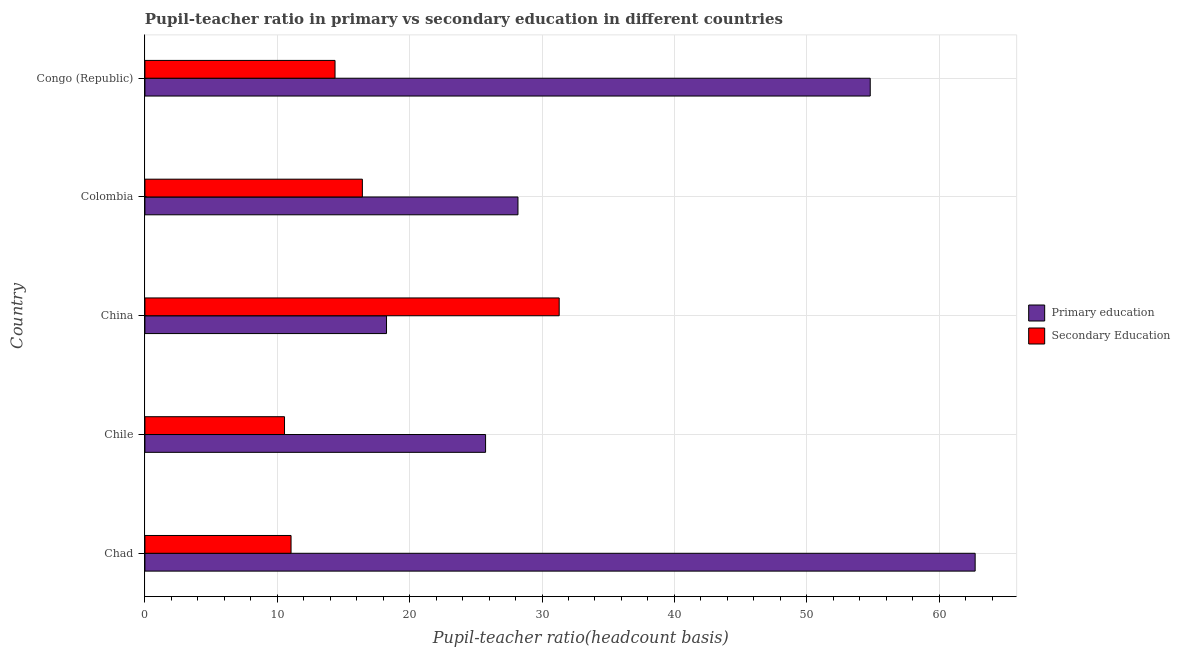How many different coloured bars are there?
Your response must be concise. 2. How many groups of bars are there?
Your answer should be compact. 5. Are the number of bars on each tick of the Y-axis equal?
Your response must be concise. Yes. How many bars are there on the 5th tick from the top?
Give a very brief answer. 2. What is the label of the 2nd group of bars from the top?
Your answer should be very brief. Colombia. What is the pupil-teacher ratio in primary education in Chad?
Provide a succinct answer. 62.72. Across all countries, what is the maximum pupil-teacher ratio in primary education?
Keep it short and to the point. 62.72. Across all countries, what is the minimum pupil-teacher ratio in primary education?
Give a very brief answer. 18.25. In which country was the pupil-teacher ratio in primary education maximum?
Your answer should be very brief. Chad. In which country was the pupil-teacher ratio in primary education minimum?
Provide a short and direct response. China. What is the total pupil teacher ratio on secondary education in the graph?
Your response must be concise. 83.67. What is the difference between the pupil teacher ratio on secondary education in Chad and that in Colombia?
Offer a terse response. -5.39. What is the difference between the pupil teacher ratio on secondary education in Colombia and the pupil-teacher ratio in primary education in Congo (Republic)?
Provide a succinct answer. -38.37. What is the average pupil teacher ratio on secondary education per country?
Offer a very short reply. 16.73. What is the difference between the pupil teacher ratio on secondary education and pupil-teacher ratio in primary education in China?
Your response must be concise. 13.05. In how many countries, is the pupil-teacher ratio in primary education greater than 58 ?
Offer a very short reply. 1. What is the ratio of the pupil teacher ratio on secondary education in Chad to that in China?
Offer a terse response. 0.35. Is the pupil-teacher ratio in primary education in Chile less than that in Colombia?
Make the answer very short. Yes. Is the difference between the pupil-teacher ratio in primary education in China and Congo (Republic) greater than the difference between the pupil teacher ratio on secondary education in China and Congo (Republic)?
Make the answer very short. No. What is the difference between the highest and the second highest pupil teacher ratio on secondary education?
Ensure brevity in your answer.  14.87. What is the difference between the highest and the lowest pupil-teacher ratio in primary education?
Offer a very short reply. 44.47. What does the 1st bar from the top in Chad represents?
Offer a very short reply. Secondary Education. How many bars are there?
Your response must be concise. 10. What is the difference between two consecutive major ticks on the X-axis?
Provide a short and direct response. 10. Are the values on the major ticks of X-axis written in scientific E-notation?
Provide a short and direct response. No. How are the legend labels stacked?
Ensure brevity in your answer.  Vertical. What is the title of the graph?
Provide a short and direct response. Pupil-teacher ratio in primary vs secondary education in different countries. Does "Forest land" appear as one of the legend labels in the graph?
Offer a very short reply. No. What is the label or title of the X-axis?
Your response must be concise. Pupil-teacher ratio(headcount basis). What is the Pupil-teacher ratio(headcount basis) in Primary education in Chad?
Ensure brevity in your answer.  62.72. What is the Pupil-teacher ratio(headcount basis) in Secondary Education in Chad?
Provide a short and direct response. 11.04. What is the Pupil-teacher ratio(headcount basis) in Primary education in Chile?
Ensure brevity in your answer.  25.74. What is the Pupil-teacher ratio(headcount basis) of Secondary Education in Chile?
Make the answer very short. 10.55. What is the Pupil-teacher ratio(headcount basis) in Primary education in China?
Offer a terse response. 18.25. What is the Pupil-teacher ratio(headcount basis) in Secondary Education in China?
Give a very brief answer. 31.3. What is the Pupil-teacher ratio(headcount basis) of Primary education in Colombia?
Provide a short and direct response. 28.18. What is the Pupil-teacher ratio(headcount basis) of Secondary Education in Colombia?
Your response must be concise. 16.43. What is the Pupil-teacher ratio(headcount basis) of Primary education in Congo (Republic)?
Make the answer very short. 54.8. What is the Pupil-teacher ratio(headcount basis) in Secondary Education in Congo (Republic)?
Give a very brief answer. 14.36. Across all countries, what is the maximum Pupil-teacher ratio(headcount basis) in Primary education?
Your answer should be compact. 62.72. Across all countries, what is the maximum Pupil-teacher ratio(headcount basis) in Secondary Education?
Make the answer very short. 31.3. Across all countries, what is the minimum Pupil-teacher ratio(headcount basis) in Primary education?
Ensure brevity in your answer.  18.25. Across all countries, what is the minimum Pupil-teacher ratio(headcount basis) in Secondary Education?
Your answer should be compact. 10.55. What is the total Pupil-teacher ratio(headcount basis) in Primary education in the graph?
Your answer should be very brief. 189.69. What is the total Pupil-teacher ratio(headcount basis) of Secondary Education in the graph?
Offer a terse response. 83.67. What is the difference between the Pupil-teacher ratio(headcount basis) in Primary education in Chad and that in Chile?
Offer a terse response. 36.99. What is the difference between the Pupil-teacher ratio(headcount basis) of Secondary Education in Chad and that in Chile?
Your response must be concise. 0.49. What is the difference between the Pupil-teacher ratio(headcount basis) of Primary education in Chad and that in China?
Provide a short and direct response. 44.47. What is the difference between the Pupil-teacher ratio(headcount basis) of Secondary Education in Chad and that in China?
Make the answer very short. -20.26. What is the difference between the Pupil-teacher ratio(headcount basis) of Primary education in Chad and that in Colombia?
Offer a very short reply. 34.54. What is the difference between the Pupil-teacher ratio(headcount basis) in Secondary Education in Chad and that in Colombia?
Provide a short and direct response. -5.39. What is the difference between the Pupil-teacher ratio(headcount basis) of Primary education in Chad and that in Congo (Republic)?
Keep it short and to the point. 7.93. What is the difference between the Pupil-teacher ratio(headcount basis) in Secondary Education in Chad and that in Congo (Republic)?
Give a very brief answer. -3.32. What is the difference between the Pupil-teacher ratio(headcount basis) in Primary education in Chile and that in China?
Your answer should be very brief. 7.48. What is the difference between the Pupil-teacher ratio(headcount basis) in Secondary Education in Chile and that in China?
Provide a short and direct response. -20.75. What is the difference between the Pupil-teacher ratio(headcount basis) in Primary education in Chile and that in Colombia?
Keep it short and to the point. -2.45. What is the difference between the Pupil-teacher ratio(headcount basis) of Secondary Education in Chile and that in Colombia?
Give a very brief answer. -5.88. What is the difference between the Pupil-teacher ratio(headcount basis) in Primary education in Chile and that in Congo (Republic)?
Offer a terse response. -29.06. What is the difference between the Pupil-teacher ratio(headcount basis) in Secondary Education in Chile and that in Congo (Republic)?
Offer a very short reply. -3.82. What is the difference between the Pupil-teacher ratio(headcount basis) in Primary education in China and that in Colombia?
Provide a succinct answer. -9.93. What is the difference between the Pupil-teacher ratio(headcount basis) of Secondary Education in China and that in Colombia?
Offer a very short reply. 14.87. What is the difference between the Pupil-teacher ratio(headcount basis) of Primary education in China and that in Congo (Republic)?
Keep it short and to the point. -36.54. What is the difference between the Pupil-teacher ratio(headcount basis) of Secondary Education in China and that in Congo (Republic)?
Ensure brevity in your answer.  16.94. What is the difference between the Pupil-teacher ratio(headcount basis) of Primary education in Colombia and that in Congo (Republic)?
Your response must be concise. -26.61. What is the difference between the Pupil-teacher ratio(headcount basis) of Secondary Education in Colombia and that in Congo (Republic)?
Ensure brevity in your answer.  2.07. What is the difference between the Pupil-teacher ratio(headcount basis) of Primary education in Chad and the Pupil-teacher ratio(headcount basis) of Secondary Education in Chile?
Provide a short and direct response. 52.18. What is the difference between the Pupil-teacher ratio(headcount basis) in Primary education in Chad and the Pupil-teacher ratio(headcount basis) in Secondary Education in China?
Keep it short and to the point. 31.43. What is the difference between the Pupil-teacher ratio(headcount basis) in Primary education in Chad and the Pupil-teacher ratio(headcount basis) in Secondary Education in Colombia?
Provide a succinct answer. 46.29. What is the difference between the Pupil-teacher ratio(headcount basis) in Primary education in Chad and the Pupil-teacher ratio(headcount basis) in Secondary Education in Congo (Republic)?
Offer a terse response. 48.36. What is the difference between the Pupil-teacher ratio(headcount basis) of Primary education in Chile and the Pupil-teacher ratio(headcount basis) of Secondary Education in China?
Provide a succinct answer. -5.56. What is the difference between the Pupil-teacher ratio(headcount basis) of Primary education in Chile and the Pupil-teacher ratio(headcount basis) of Secondary Education in Colombia?
Give a very brief answer. 9.31. What is the difference between the Pupil-teacher ratio(headcount basis) in Primary education in Chile and the Pupil-teacher ratio(headcount basis) in Secondary Education in Congo (Republic)?
Your answer should be compact. 11.37. What is the difference between the Pupil-teacher ratio(headcount basis) of Primary education in China and the Pupil-teacher ratio(headcount basis) of Secondary Education in Colombia?
Offer a terse response. 1.82. What is the difference between the Pupil-teacher ratio(headcount basis) of Primary education in China and the Pupil-teacher ratio(headcount basis) of Secondary Education in Congo (Republic)?
Provide a succinct answer. 3.89. What is the difference between the Pupil-teacher ratio(headcount basis) in Primary education in Colombia and the Pupil-teacher ratio(headcount basis) in Secondary Education in Congo (Republic)?
Give a very brief answer. 13.82. What is the average Pupil-teacher ratio(headcount basis) in Primary education per country?
Offer a terse response. 37.94. What is the average Pupil-teacher ratio(headcount basis) of Secondary Education per country?
Offer a terse response. 16.73. What is the difference between the Pupil-teacher ratio(headcount basis) of Primary education and Pupil-teacher ratio(headcount basis) of Secondary Education in Chad?
Keep it short and to the point. 51.68. What is the difference between the Pupil-teacher ratio(headcount basis) of Primary education and Pupil-teacher ratio(headcount basis) of Secondary Education in Chile?
Your answer should be very brief. 15.19. What is the difference between the Pupil-teacher ratio(headcount basis) in Primary education and Pupil-teacher ratio(headcount basis) in Secondary Education in China?
Offer a terse response. -13.05. What is the difference between the Pupil-teacher ratio(headcount basis) of Primary education and Pupil-teacher ratio(headcount basis) of Secondary Education in Colombia?
Your response must be concise. 11.75. What is the difference between the Pupil-teacher ratio(headcount basis) in Primary education and Pupil-teacher ratio(headcount basis) in Secondary Education in Congo (Republic)?
Make the answer very short. 40.43. What is the ratio of the Pupil-teacher ratio(headcount basis) in Primary education in Chad to that in Chile?
Give a very brief answer. 2.44. What is the ratio of the Pupil-teacher ratio(headcount basis) in Secondary Education in Chad to that in Chile?
Your answer should be compact. 1.05. What is the ratio of the Pupil-teacher ratio(headcount basis) of Primary education in Chad to that in China?
Provide a succinct answer. 3.44. What is the ratio of the Pupil-teacher ratio(headcount basis) of Secondary Education in Chad to that in China?
Provide a short and direct response. 0.35. What is the ratio of the Pupil-teacher ratio(headcount basis) of Primary education in Chad to that in Colombia?
Provide a short and direct response. 2.23. What is the ratio of the Pupil-teacher ratio(headcount basis) in Secondary Education in Chad to that in Colombia?
Your answer should be compact. 0.67. What is the ratio of the Pupil-teacher ratio(headcount basis) in Primary education in Chad to that in Congo (Republic)?
Make the answer very short. 1.14. What is the ratio of the Pupil-teacher ratio(headcount basis) in Secondary Education in Chad to that in Congo (Republic)?
Give a very brief answer. 0.77. What is the ratio of the Pupil-teacher ratio(headcount basis) of Primary education in Chile to that in China?
Provide a short and direct response. 1.41. What is the ratio of the Pupil-teacher ratio(headcount basis) in Secondary Education in Chile to that in China?
Your answer should be compact. 0.34. What is the ratio of the Pupil-teacher ratio(headcount basis) in Primary education in Chile to that in Colombia?
Make the answer very short. 0.91. What is the ratio of the Pupil-teacher ratio(headcount basis) of Secondary Education in Chile to that in Colombia?
Your answer should be very brief. 0.64. What is the ratio of the Pupil-teacher ratio(headcount basis) in Primary education in Chile to that in Congo (Republic)?
Offer a very short reply. 0.47. What is the ratio of the Pupil-teacher ratio(headcount basis) in Secondary Education in Chile to that in Congo (Republic)?
Offer a very short reply. 0.73. What is the ratio of the Pupil-teacher ratio(headcount basis) in Primary education in China to that in Colombia?
Your answer should be very brief. 0.65. What is the ratio of the Pupil-teacher ratio(headcount basis) of Secondary Education in China to that in Colombia?
Give a very brief answer. 1.91. What is the ratio of the Pupil-teacher ratio(headcount basis) in Primary education in China to that in Congo (Republic)?
Ensure brevity in your answer.  0.33. What is the ratio of the Pupil-teacher ratio(headcount basis) of Secondary Education in China to that in Congo (Republic)?
Give a very brief answer. 2.18. What is the ratio of the Pupil-teacher ratio(headcount basis) of Primary education in Colombia to that in Congo (Republic)?
Offer a very short reply. 0.51. What is the ratio of the Pupil-teacher ratio(headcount basis) of Secondary Education in Colombia to that in Congo (Republic)?
Ensure brevity in your answer.  1.14. What is the difference between the highest and the second highest Pupil-teacher ratio(headcount basis) in Primary education?
Keep it short and to the point. 7.93. What is the difference between the highest and the second highest Pupil-teacher ratio(headcount basis) of Secondary Education?
Offer a terse response. 14.87. What is the difference between the highest and the lowest Pupil-teacher ratio(headcount basis) of Primary education?
Provide a succinct answer. 44.47. What is the difference between the highest and the lowest Pupil-teacher ratio(headcount basis) of Secondary Education?
Your answer should be compact. 20.75. 